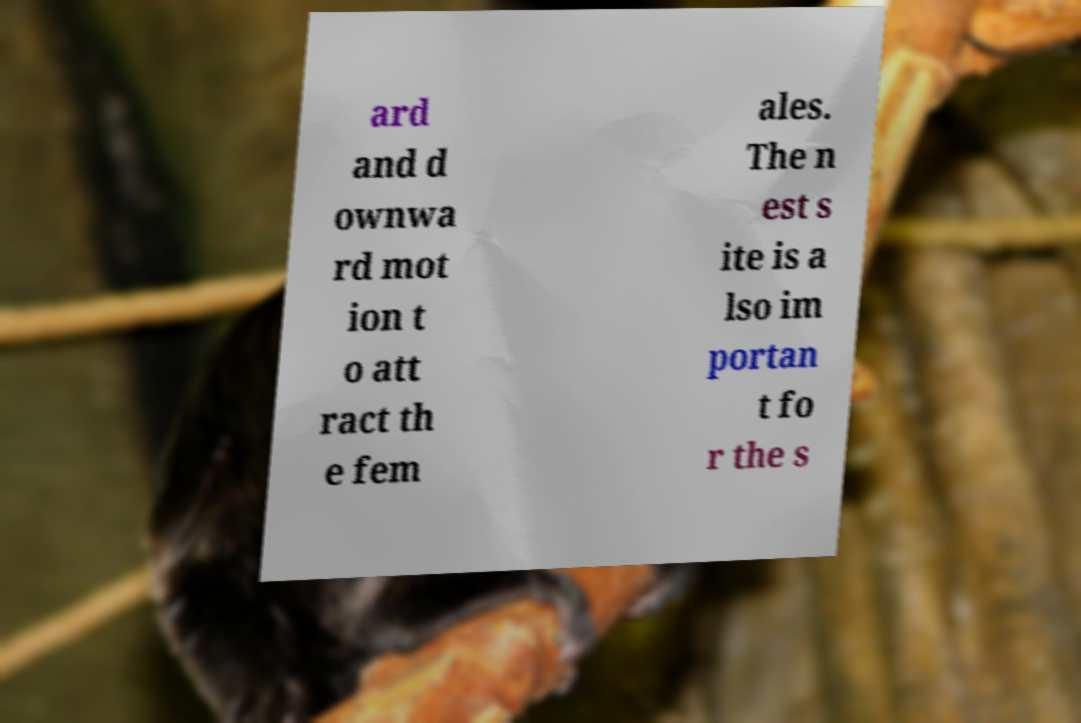Please read and relay the text visible in this image. What does it say? ard and d ownwa rd mot ion t o att ract th e fem ales. The n est s ite is a lso im portan t fo r the s 